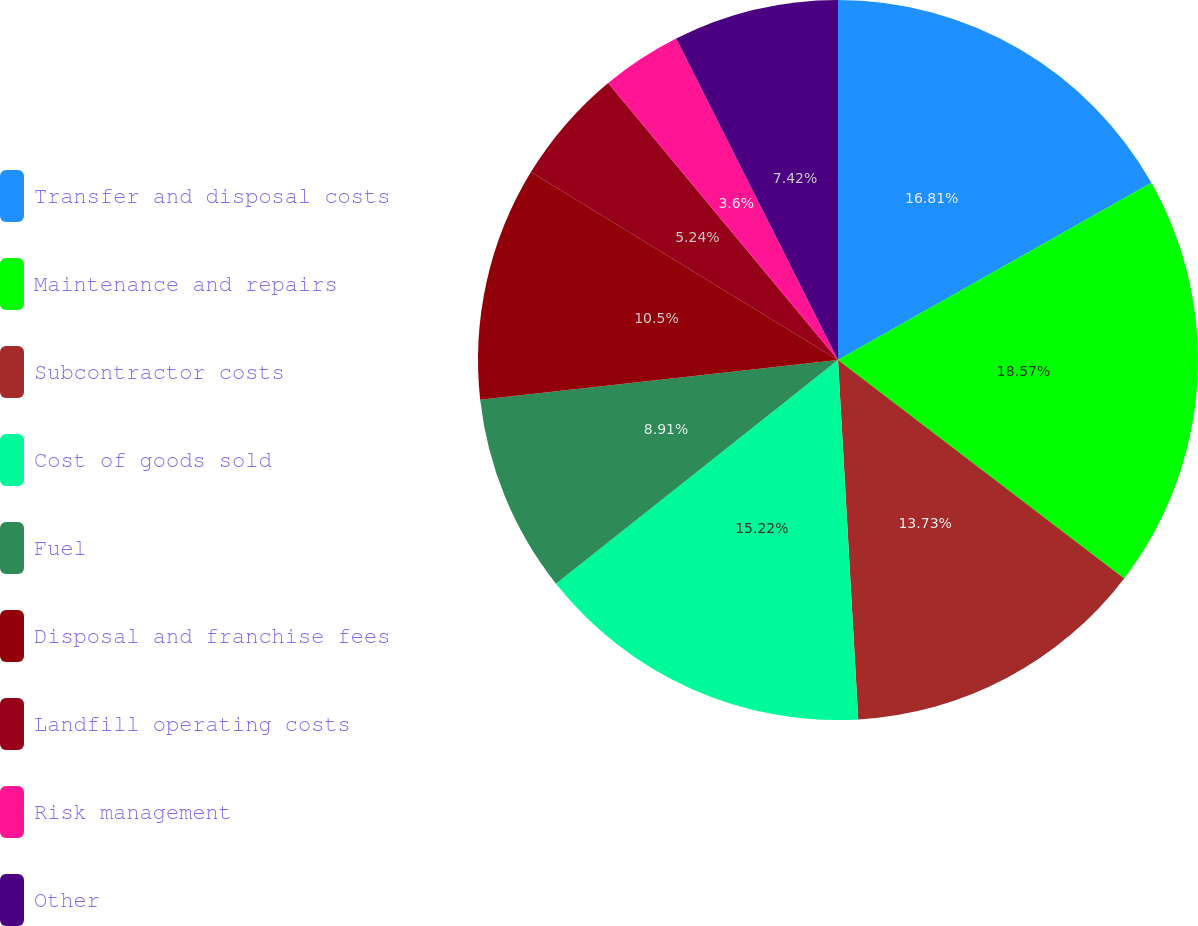Convert chart. <chart><loc_0><loc_0><loc_500><loc_500><pie_chart><fcel>Transfer and disposal costs<fcel>Maintenance and repairs<fcel>Subcontractor costs<fcel>Cost of goods sold<fcel>Fuel<fcel>Disposal and franchise fees<fcel>Landfill operating costs<fcel>Risk management<fcel>Other<nl><fcel>16.81%<fcel>18.56%<fcel>13.73%<fcel>15.22%<fcel>8.91%<fcel>10.5%<fcel>5.24%<fcel>3.6%<fcel>7.42%<nl></chart> 